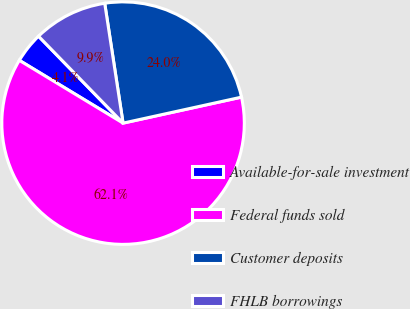Convert chart to OTSL. <chart><loc_0><loc_0><loc_500><loc_500><pie_chart><fcel>Available-for-sale investment<fcel>Federal funds sold<fcel>Customer deposits<fcel>FHLB borrowings<nl><fcel>4.06%<fcel>62.1%<fcel>23.98%<fcel>9.86%<nl></chart> 